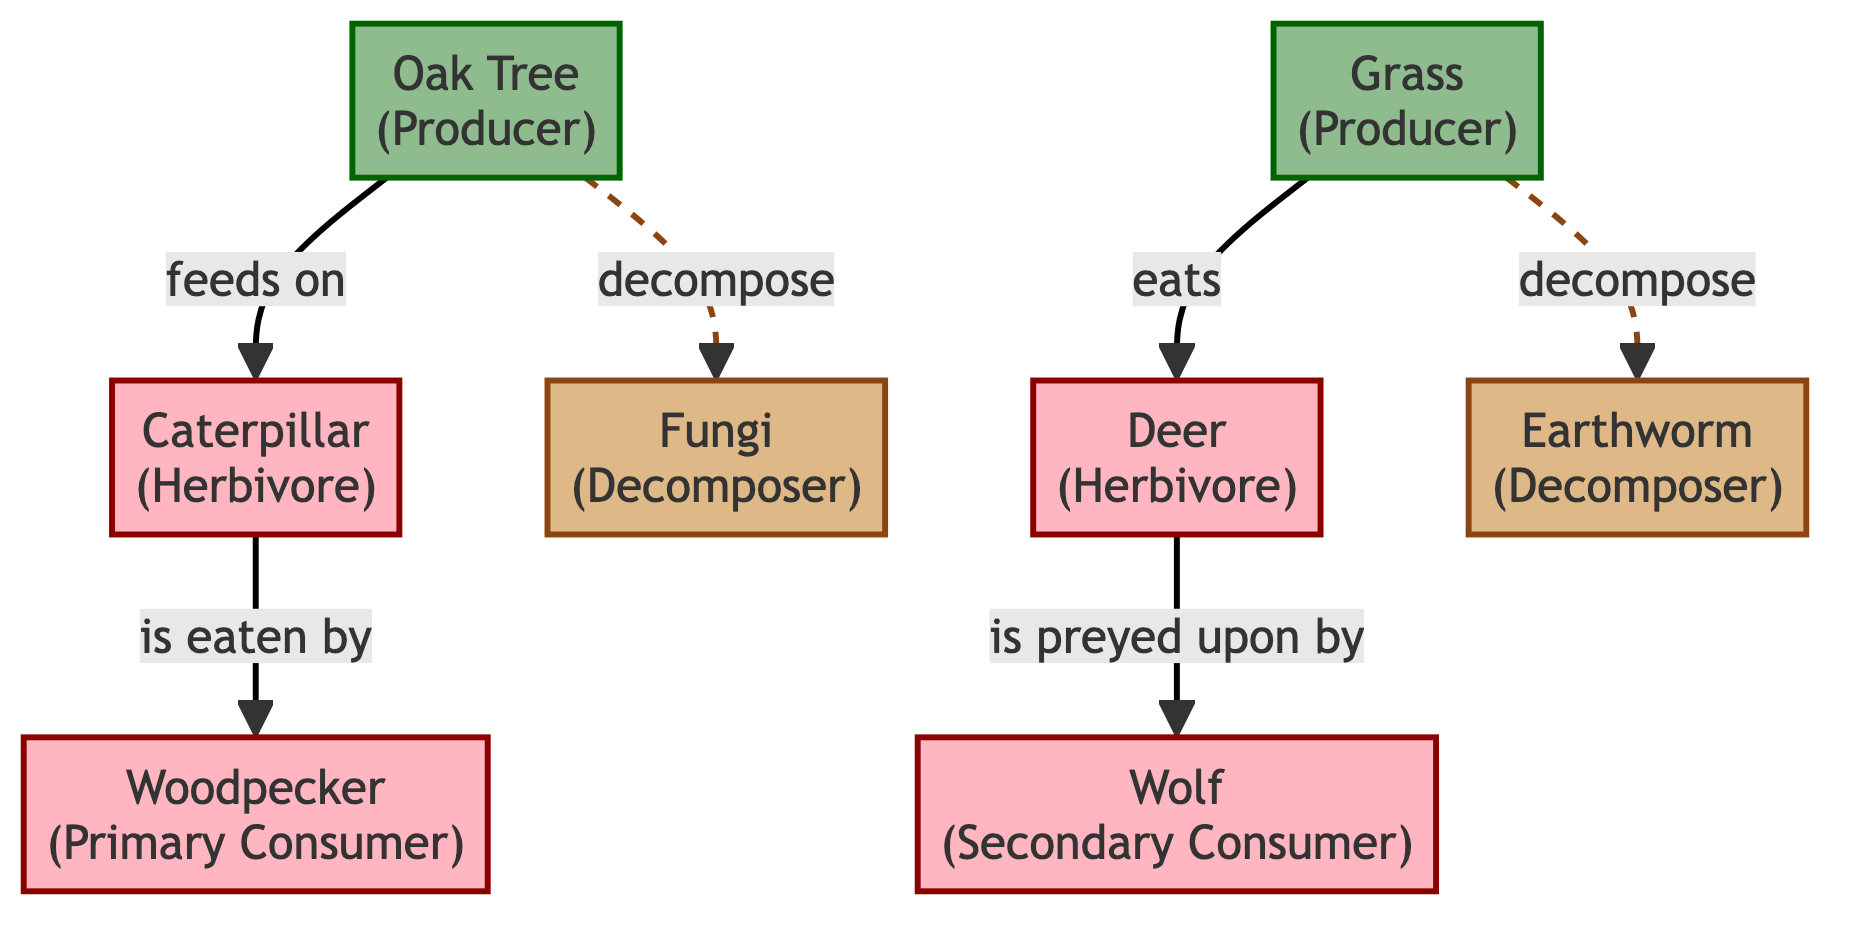What is the role of the oak tree in this food chain? The oak tree is categorized as a producer, which means it creates its own food through photosynthesis, providing energy for other organisms in the ecosystem.
Answer: Producer How many decomposers are present in the diagram? The diagram shows two decomposers: fungi and earthworm. Therefore, the total count of decomposers is simply the number of distinct decomposer nodes present.
Answer: 2 Who is eaten by the woodpecker? The woodpecker feeds on the caterpillar, which is classified as a primary consumer, indicating a direct feeding relationship shown in the diagram.
Answer: Caterpillar What type of consumer is the wolf? The wolf is classified as a secondary consumer, which implies that it feeds on primary consumers, such as deer in this food chain.
Answer: Secondary Consumer Which producers are connected to decomposers? The oak tree and grass both decompose into fungi and earthworm, respectively, indicating their connection to decomposers in the ecosystem.
Answer: Oak Tree, Grass What kind of interaction exists between deer and wolf? The interaction described in the diagram is predation, as the wolf preys on the deer, indicating a food chain relationship between the secondary consumer and the primary consumer.
Answer: Predation Identify the primary consumer in this food chain. The primary consumers present in the diagram are the caterpillar and the woodpecker; they consume producers, which allows them to be classified in this way.
Answer: Caterpillar, Woodpecker Which producer does the caterpillar feed on? The caterpillar feeds on the oak tree, as indicated by the directed edge between these two nodes in the food chain diagram.
Answer: Oak Tree 